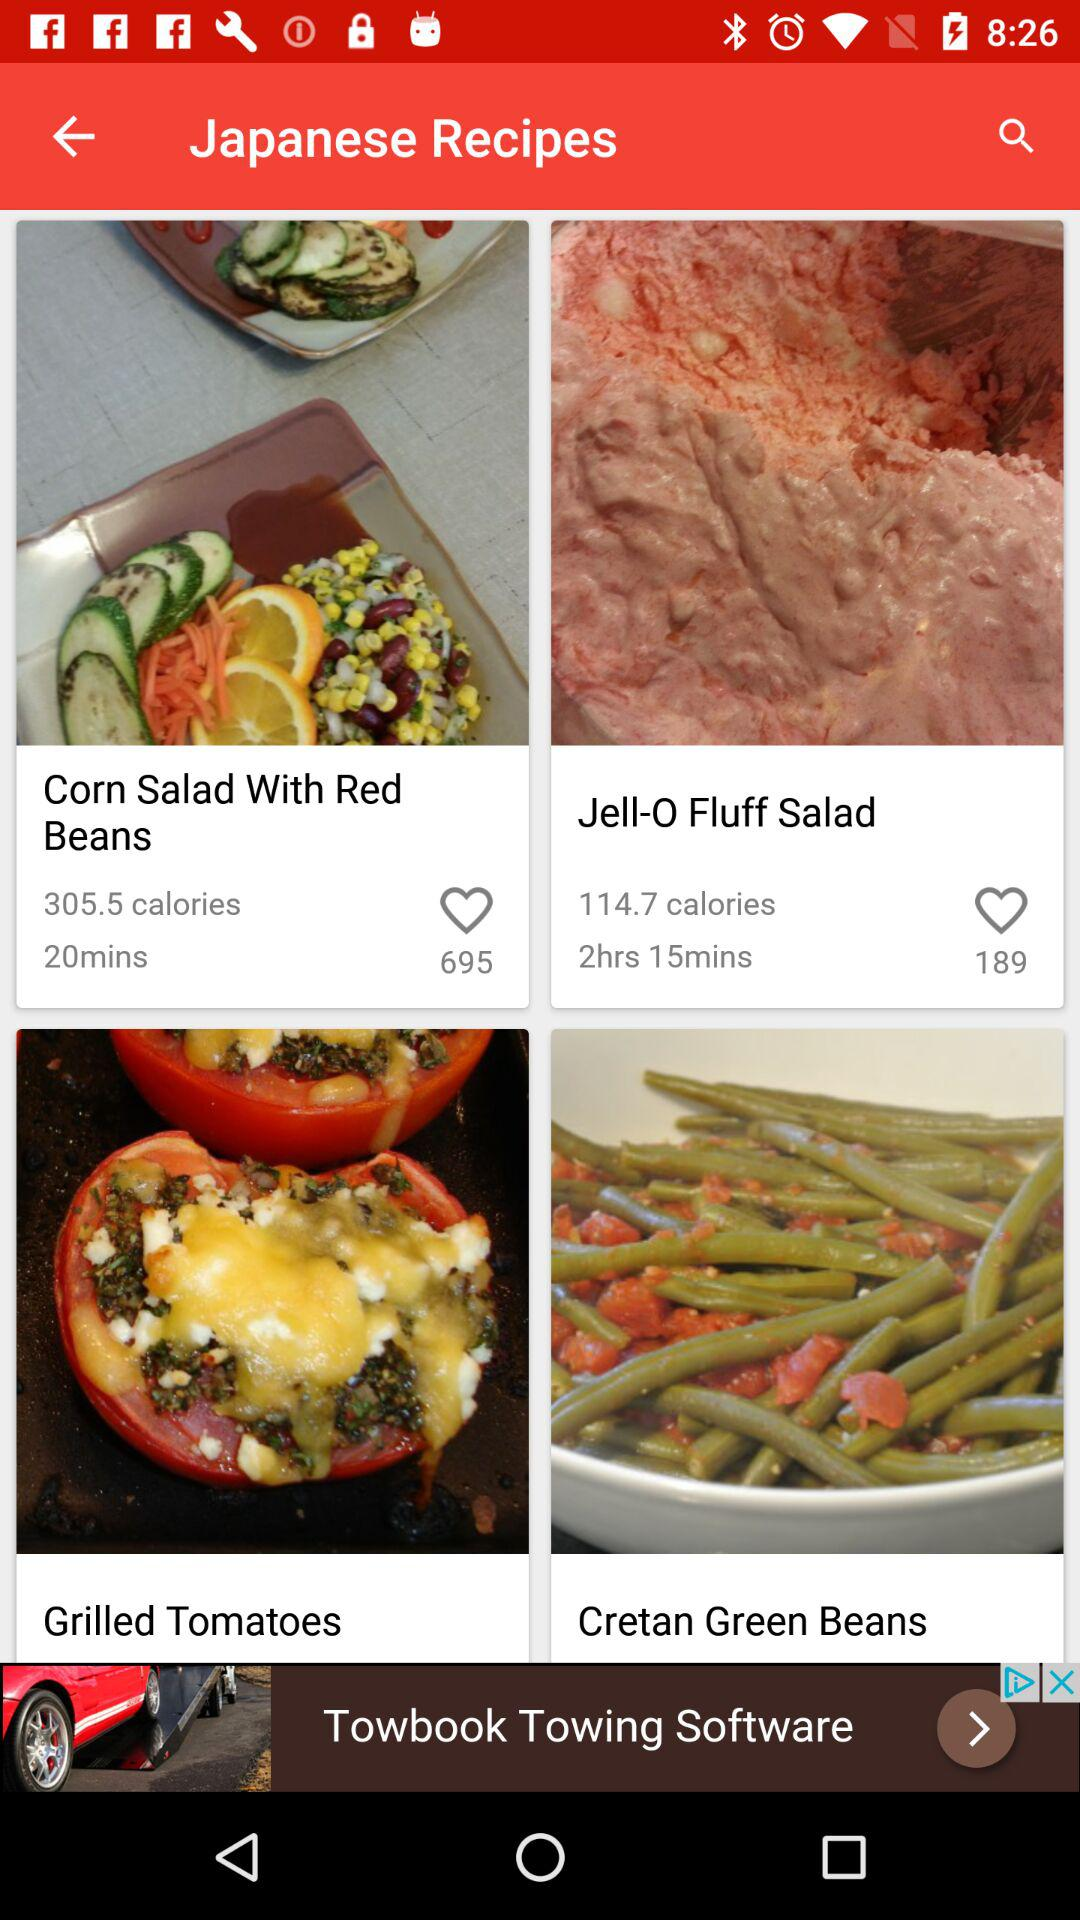How many calories are contained in the recipe for "Corn Salad With Red Beans"? There are 305.5 calories in the recipe for "Corn Salad With Red Beans". 